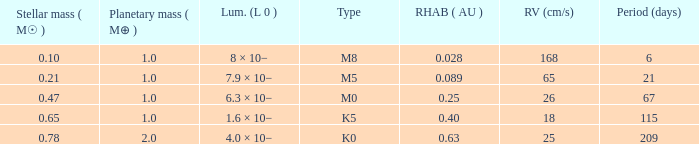What is the smallest period (days) to have a planetary mass of 1, a stellar mass greater than 0.21 and of the type M0? 67.0. 